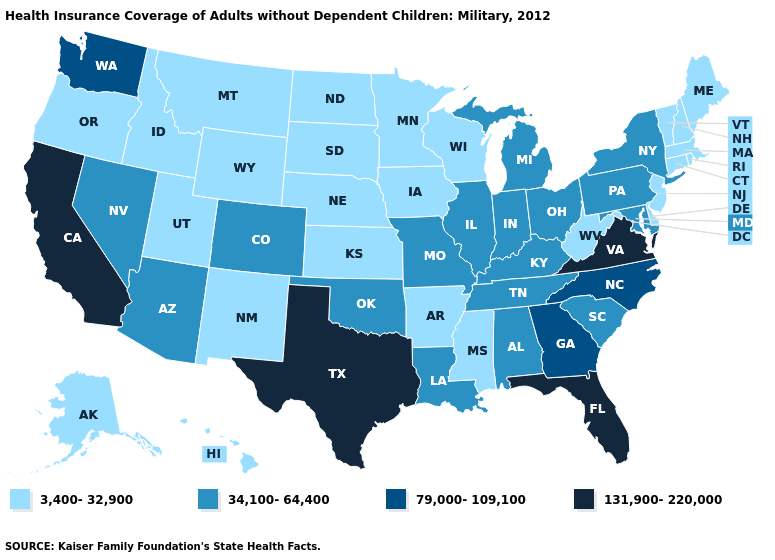Name the states that have a value in the range 79,000-109,100?
Be succinct. Georgia, North Carolina, Washington. Among the states that border Florida , which have the highest value?
Give a very brief answer. Georgia. Does the map have missing data?
Give a very brief answer. No. Among the states that border Rhode Island , which have the lowest value?
Keep it brief. Connecticut, Massachusetts. What is the lowest value in the USA?
Be succinct. 3,400-32,900. Among the states that border California , which have the lowest value?
Short answer required. Oregon. What is the value of Nevada?
Give a very brief answer. 34,100-64,400. What is the value of Vermont?
Answer briefly. 3,400-32,900. Name the states that have a value in the range 79,000-109,100?
Concise answer only. Georgia, North Carolina, Washington. What is the lowest value in the USA?
Be succinct. 3,400-32,900. Name the states that have a value in the range 3,400-32,900?
Answer briefly. Alaska, Arkansas, Connecticut, Delaware, Hawaii, Idaho, Iowa, Kansas, Maine, Massachusetts, Minnesota, Mississippi, Montana, Nebraska, New Hampshire, New Jersey, New Mexico, North Dakota, Oregon, Rhode Island, South Dakota, Utah, Vermont, West Virginia, Wisconsin, Wyoming. What is the value of Nevada?
Give a very brief answer. 34,100-64,400. Which states hav the highest value in the Northeast?
Be succinct. New York, Pennsylvania. What is the value of Hawaii?
Keep it brief. 3,400-32,900. Which states have the lowest value in the USA?
Keep it brief. Alaska, Arkansas, Connecticut, Delaware, Hawaii, Idaho, Iowa, Kansas, Maine, Massachusetts, Minnesota, Mississippi, Montana, Nebraska, New Hampshire, New Jersey, New Mexico, North Dakota, Oregon, Rhode Island, South Dakota, Utah, Vermont, West Virginia, Wisconsin, Wyoming. 